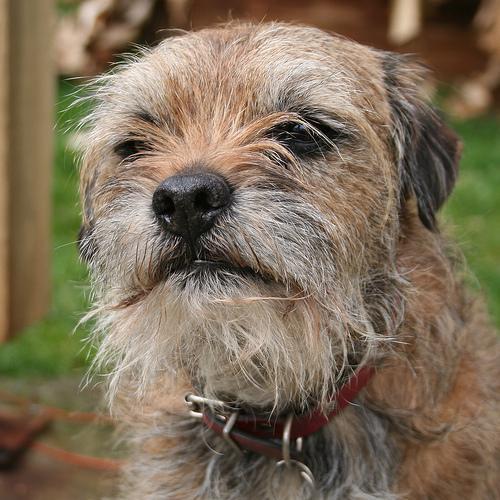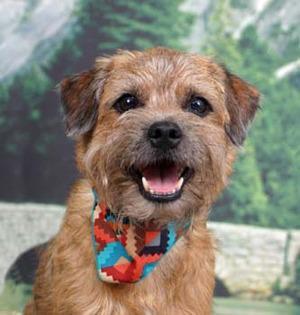The first image is the image on the left, the second image is the image on the right. Considering the images on both sides, is "One dog is wearing a collar and has its mouth closed." valid? Answer yes or no. Yes. The first image is the image on the left, the second image is the image on the right. For the images displayed, is the sentence "Left image shows a dog wearing a collar." factually correct? Answer yes or no. Yes. 